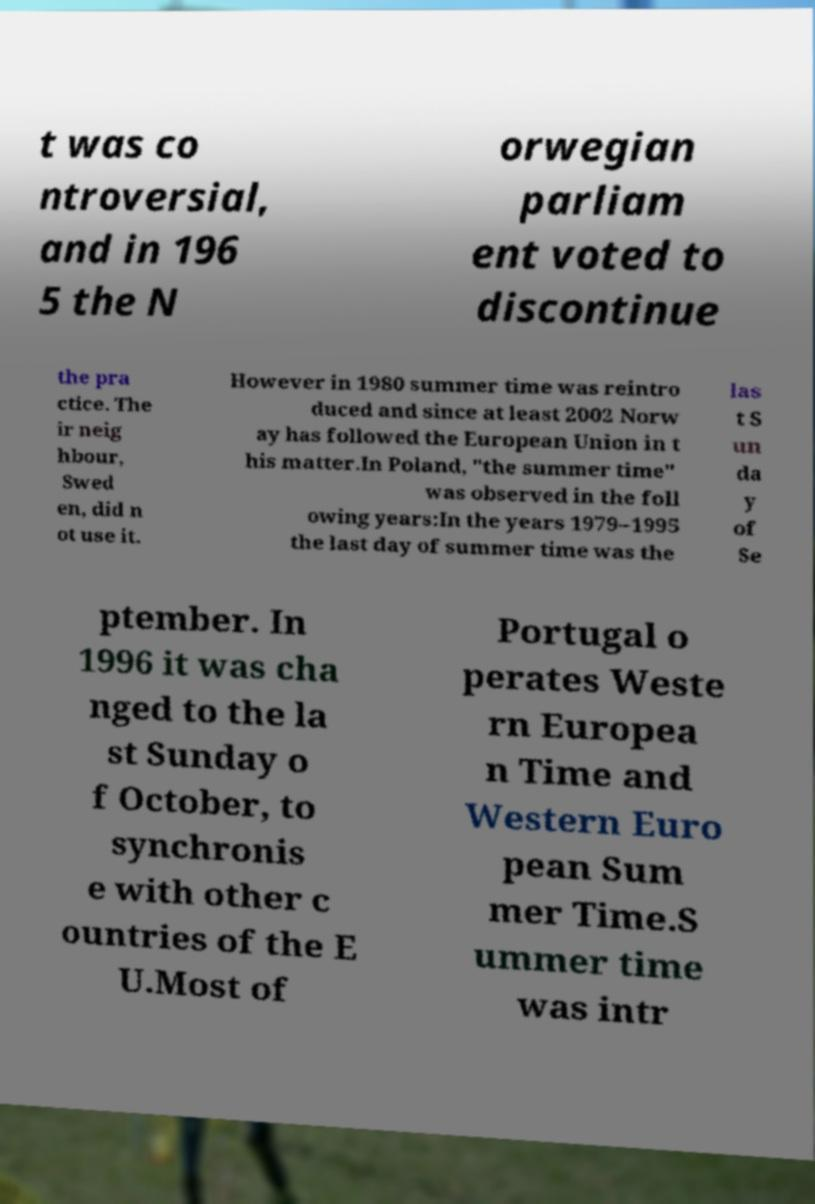I need the written content from this picture converted into text. Can you do that? t was co ntroversial, and in 196 5 the N orwegian parliam ent voted to discontinue the pra ctice. The ir neig hbour, Swed en, did n ot use it. However in 1980 summer time was reintro duced and since at least 2002 Norw ay has followed the European Union in t his matter.In Poland, "the summer time" was observed in the foll owing years:In the years 1979–1995 the last day of summer time was the las t S un da y of Se ptember. In 1996 it was cha nged to the la st Sunday o f October, to synchronis e with other c ountries of the E U.Most of Portugal o perates Weste rn Europea n Time and Western Euro pean Sum mer Time.S ummer time was intr 